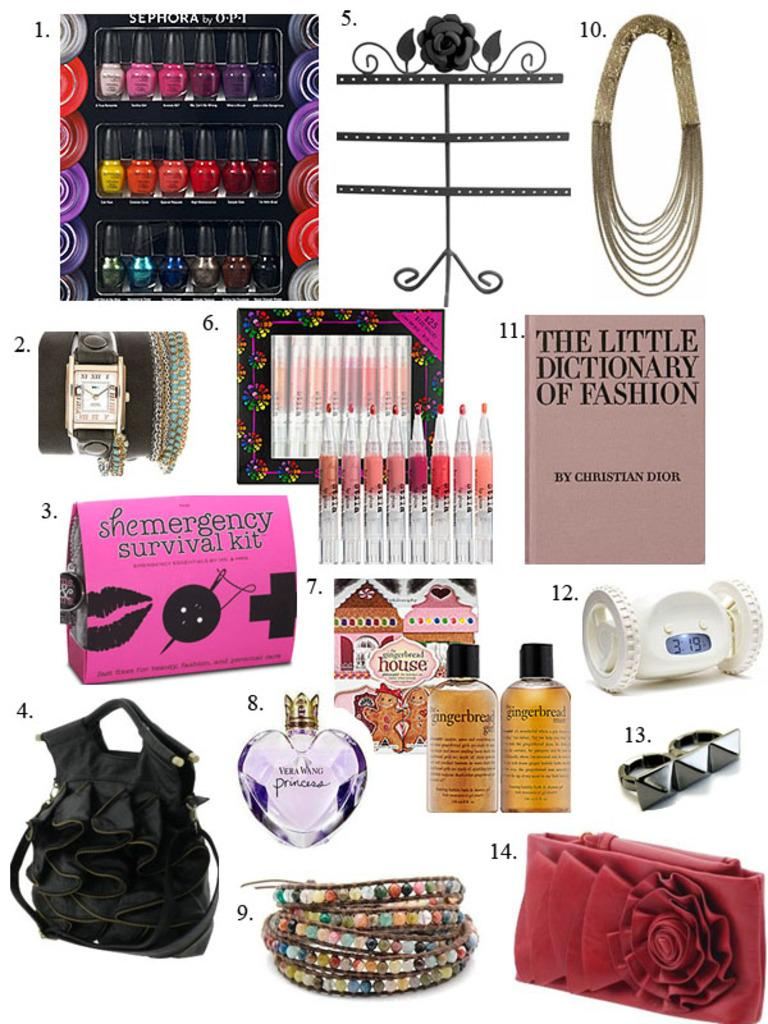<image>
Offer a succinct explanation of the picture presented. A collection of makeup applicators, perfume bottles and a book called the little dictionary of fashion. 